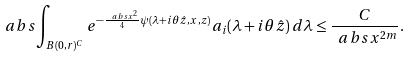<formula> <loc_0><loc_0><loc_500><loc_500>\ a b s { \int _ { B ( 0 , r ) ^ { C } } e ^ { - \frac { \ a b s { x } ^ { 2 } } { 4 } \psi ( \lambda + i \theta \hat { z } , x , z ) } a _ { i } ( \lambda + i \theta \hat { z } ) \, d \lambda } \leq \frac { C } { \ a b s { x } ^ { 2 m } } .</formula> 